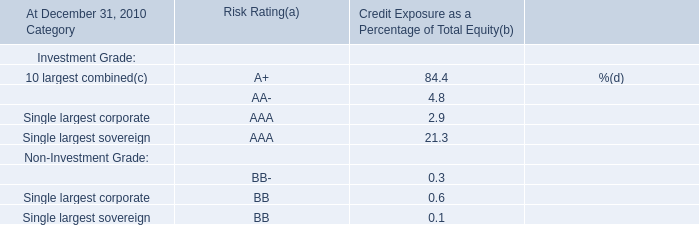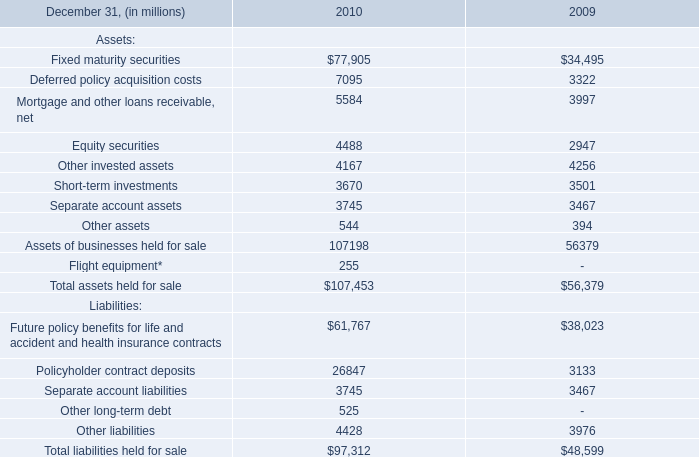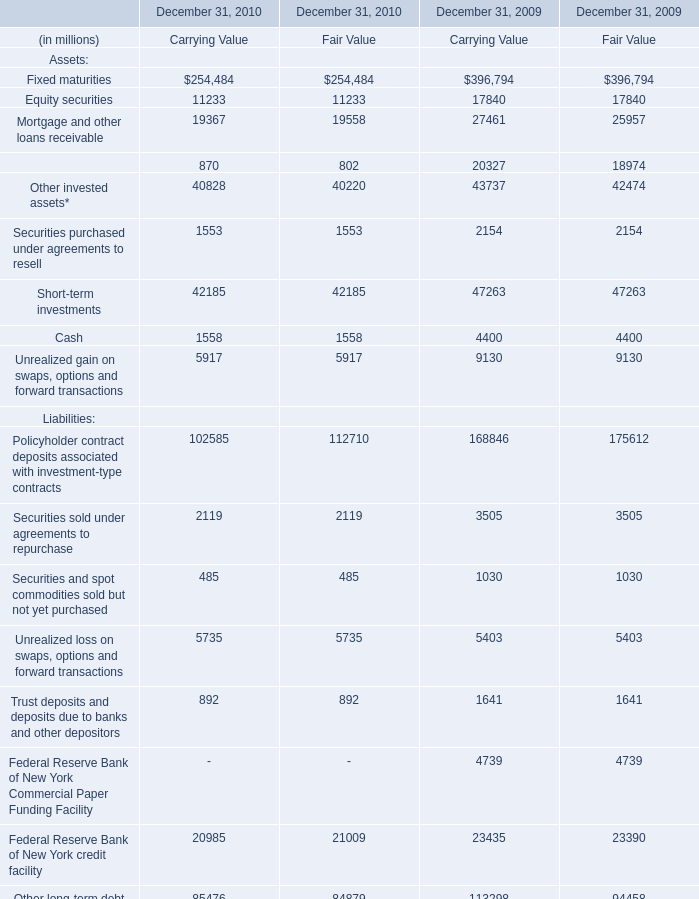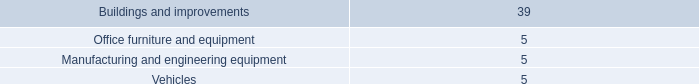What's the average of the Finance receivables, net of allowance in the years where Cash is positive? (in million) 
Computations: ((((870 + 802) + 20327) + 18974) / 2)
Answer: 20486.5. 